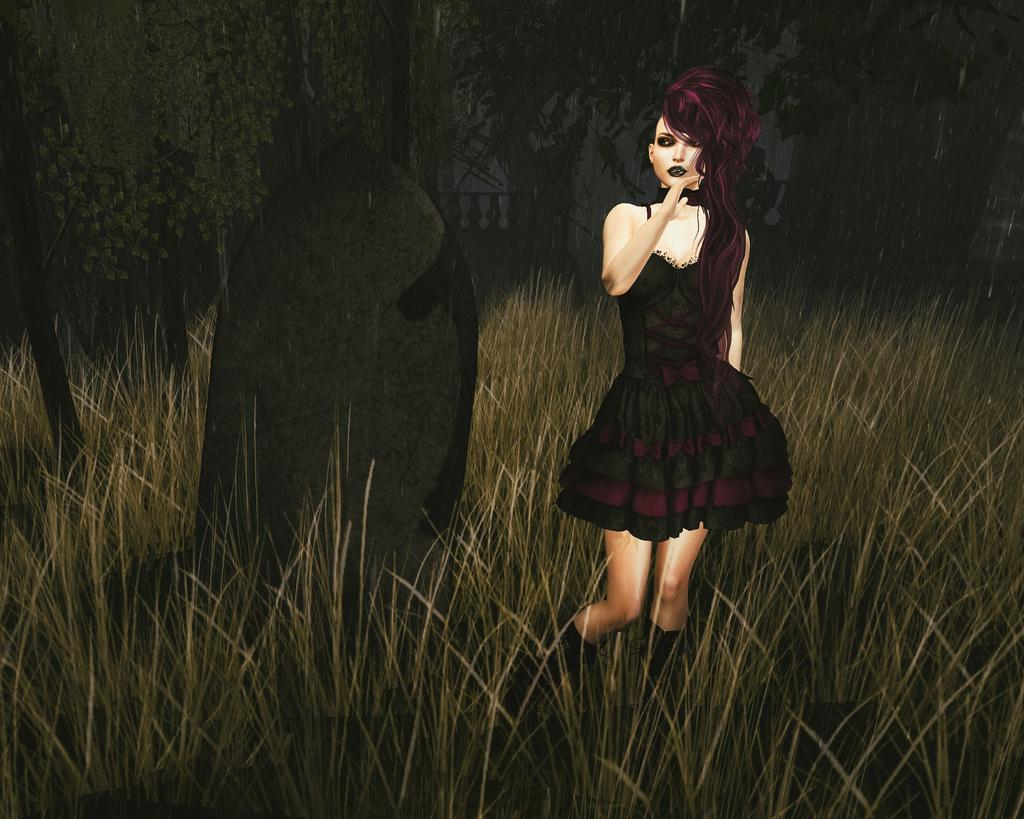Who is present in the image? There is a woman in the image. What is the woman standing on? The woman is standing on a path. What can be seen behind the woman? There are trees behind the woman. What type of vegetation is visible in the image? There is grass visible in the image. What type of plot is the woman planning in the image? There is no indication in the image that the woman is planning a plot, as the facts provided do not mention any such activity. 